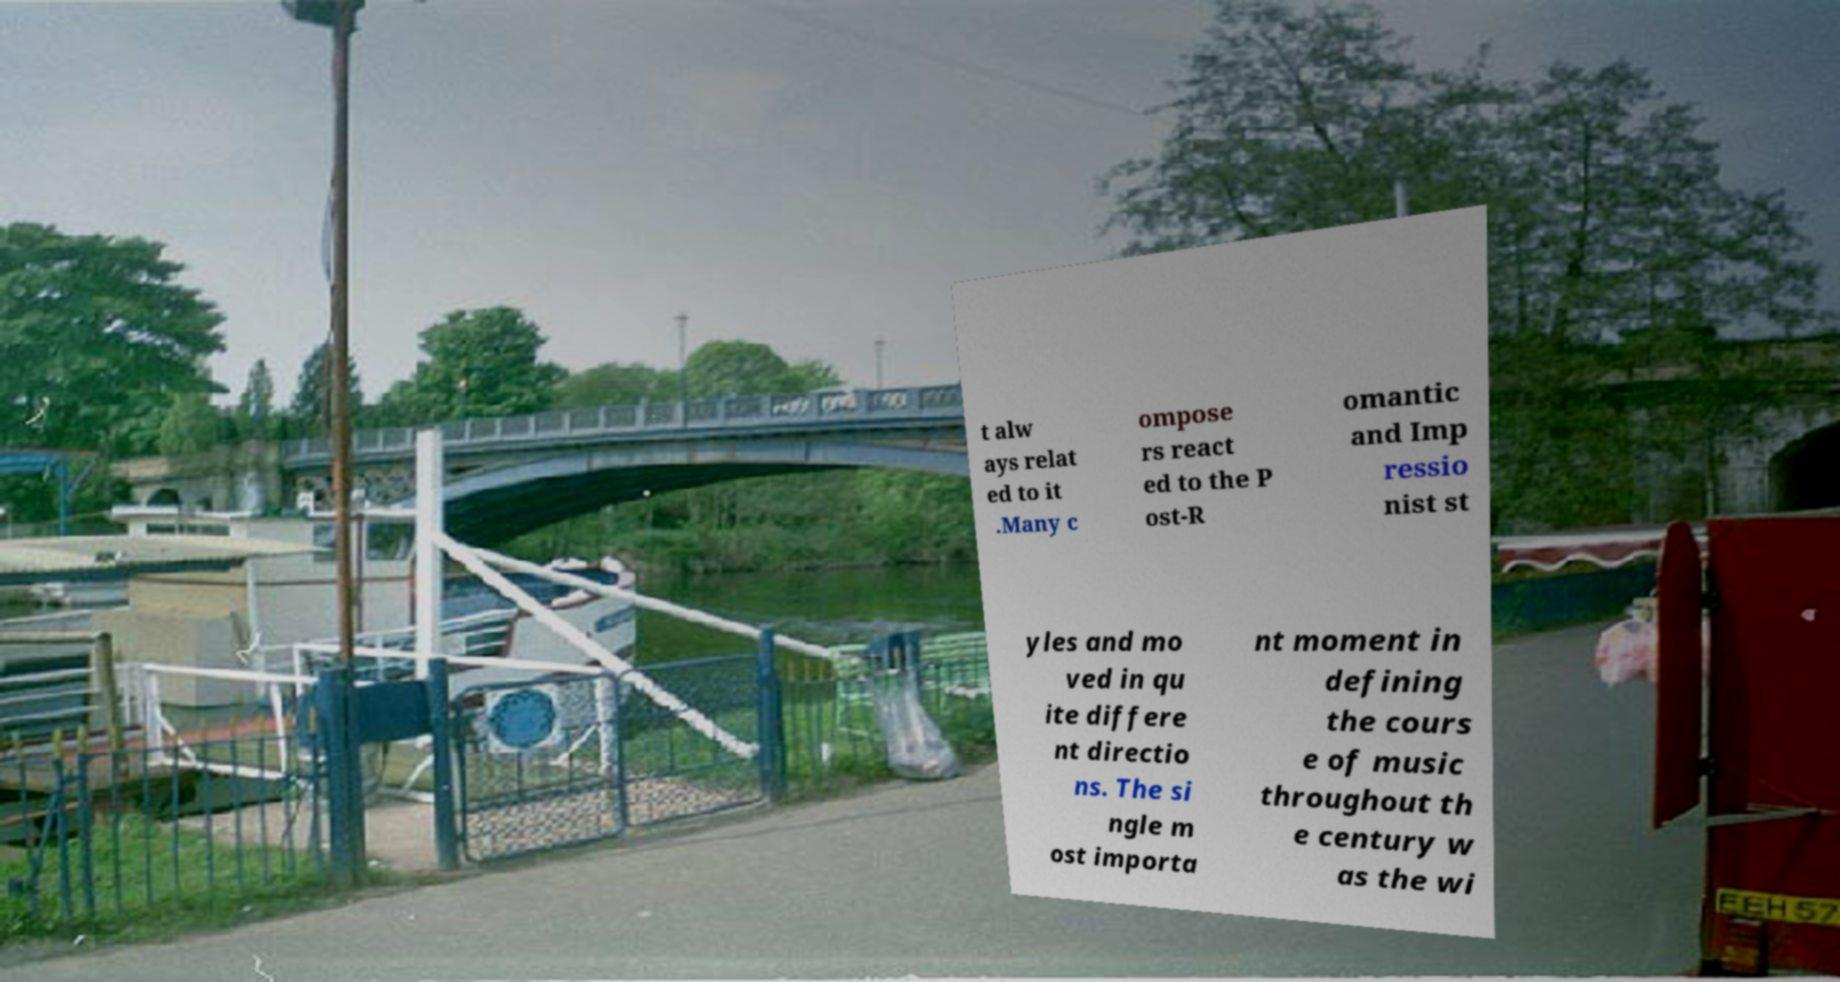There's text embedded in this image that I need extracted. Can you transcribe it verbatim? t alw ays relat ed to it .Many c ompose rs react ed to the P ost-R omantic and Imp ressio nist st yles and mo ved in qu ite differe nt directio ns. The si ngle m ost importa nt moment in defining the cours e of music throughout th e century w as the wi 